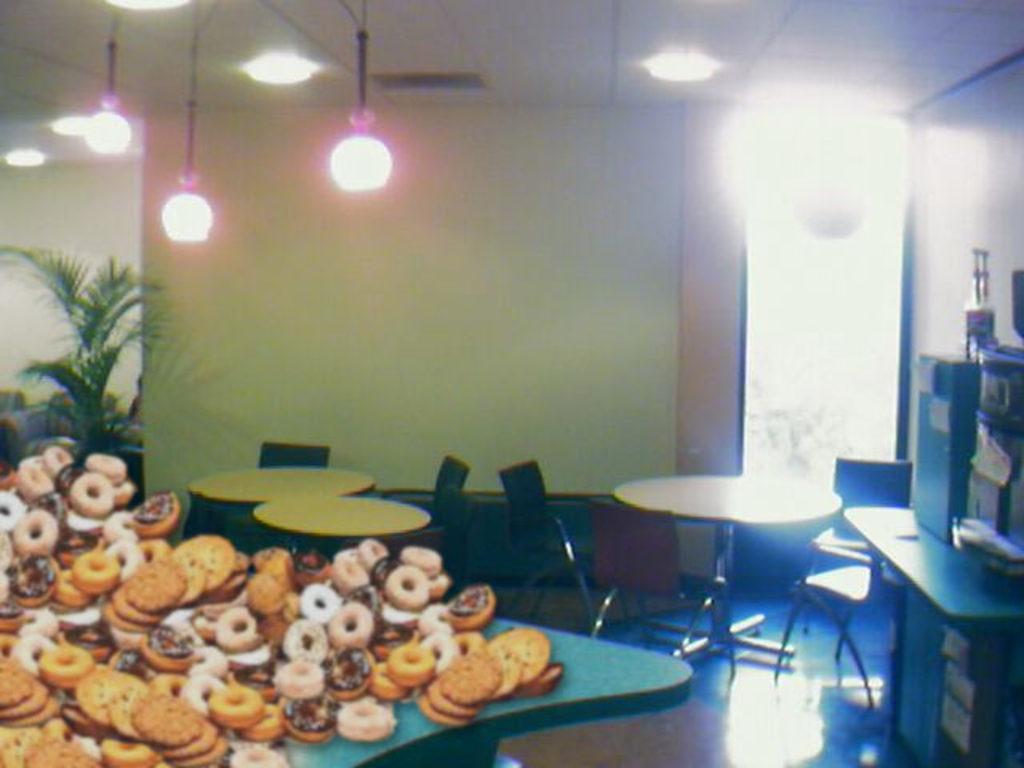Could you give a brief overview of what you see in this image? In the foreground of this image, there are donuts on the table. In the background, there are chairs, tables, wall, a plant, ceiling, lights and a few objects on the table on the right side. 